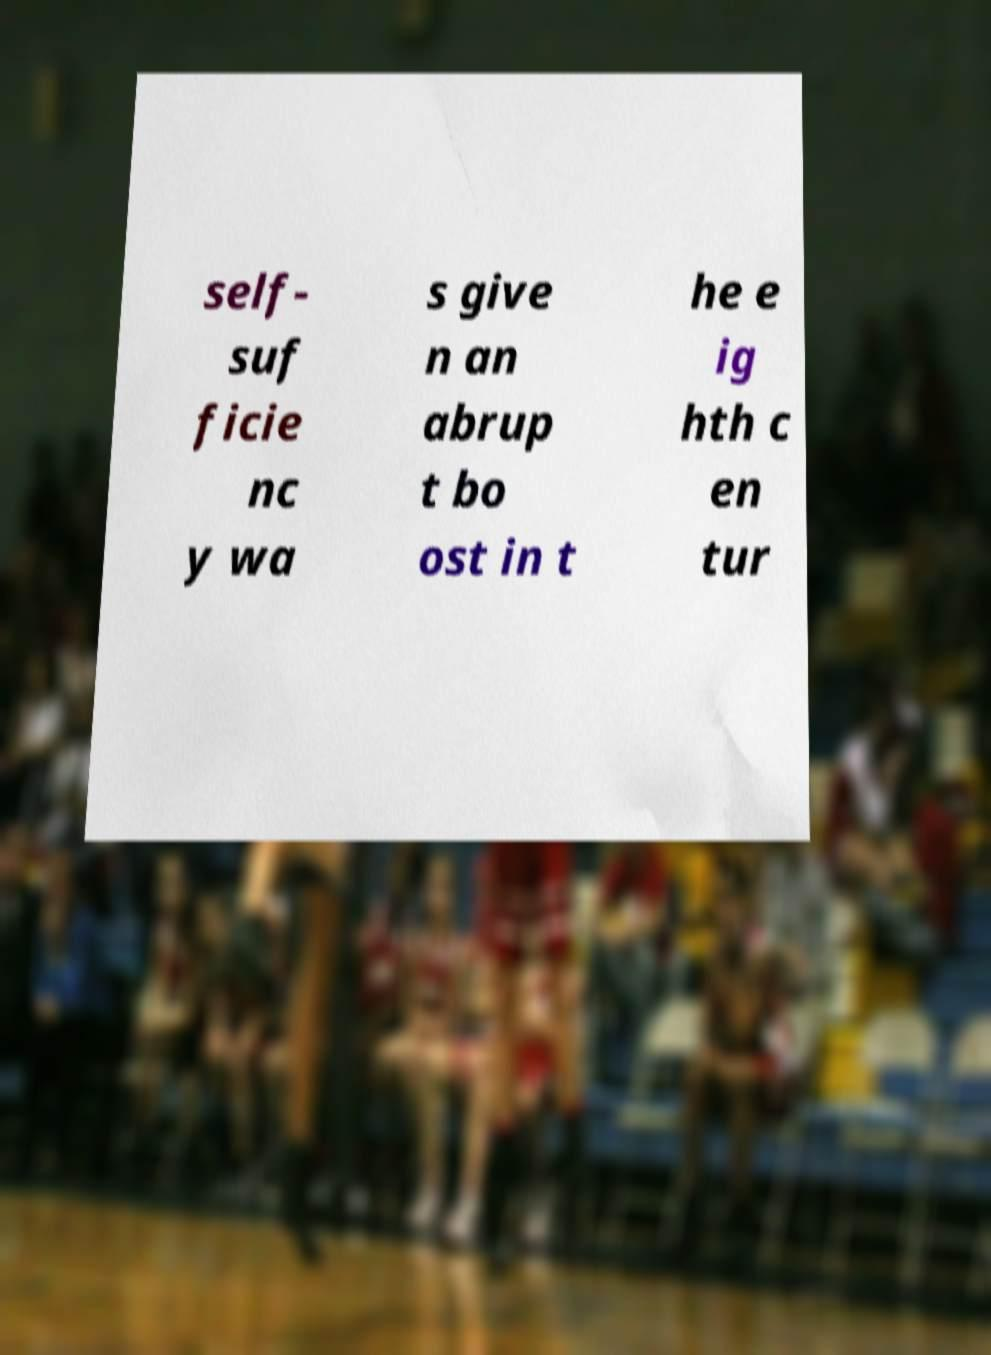For documentation purposes, I need the text within this image transcribed. Could you provide that? self- suf ficie nc y wa s give n an abrup t bo ost in t he e ig hth c en tur 